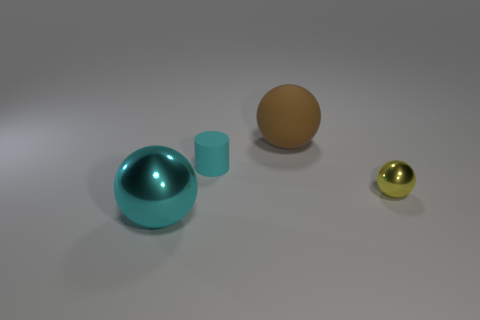Add 1 metallic blocks. How many objects exist? 5 Subtract all cylinders. How many objects are left? 3 Subtract all small cyan rubber things. Subtract all large cyan shiny balls. How many objects are left? 2 Add 1 large brown rubber balls. How many large brown rubber balls are left? 2 Add 1 big purple rubber balls. How many big purple rubber balls exist? 1 Subtract 1 brown balls. How many objects are left? 3 